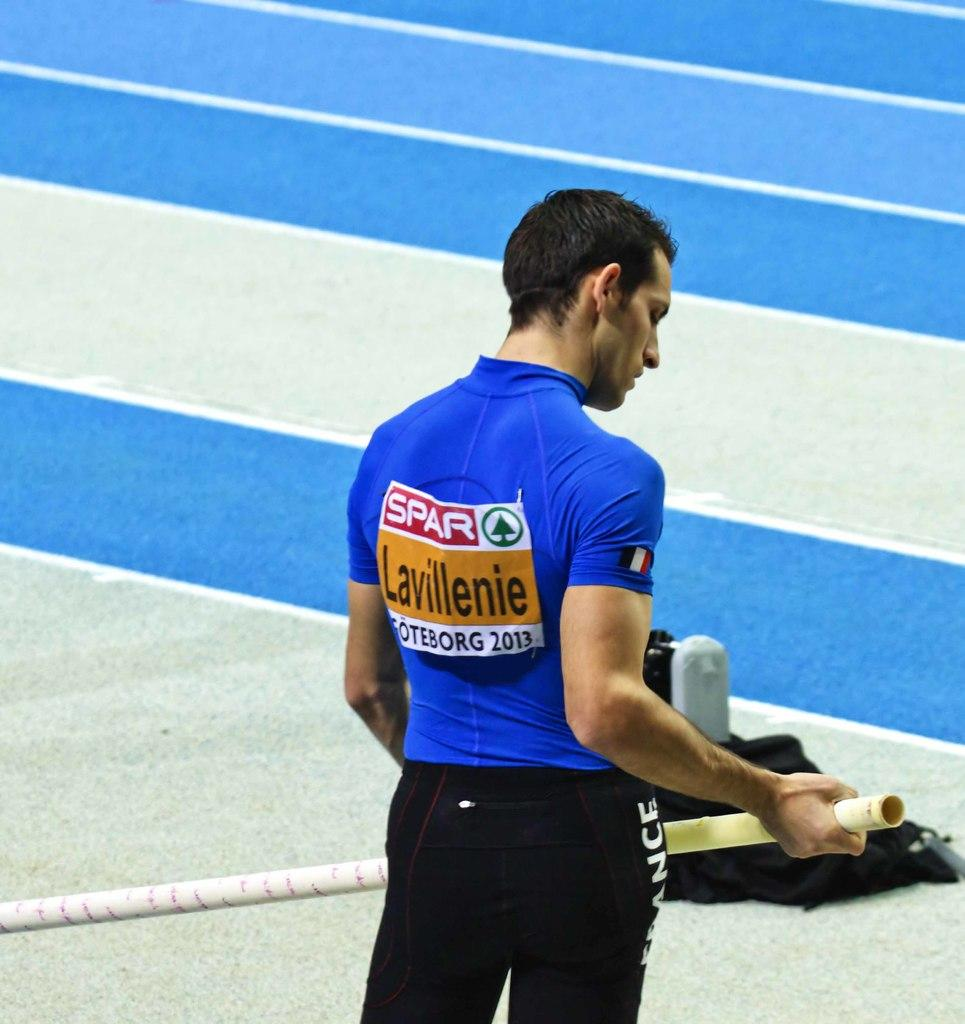<image>
Write a terse but informative summary of the picture. Lavillenie is the pole vaulter wearing the blue shirt. 